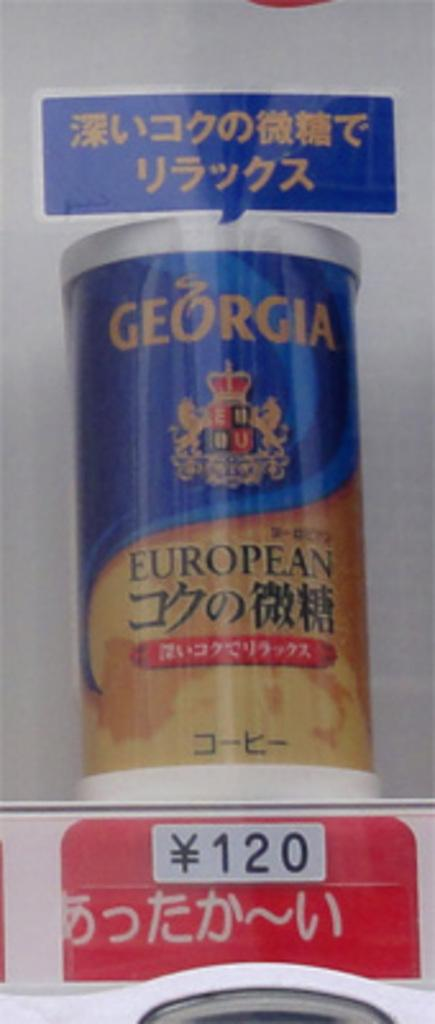Provide a one-sentence caption for the provided image. A Georgia product that can be purchased for a cost of 120 of the local currency. 